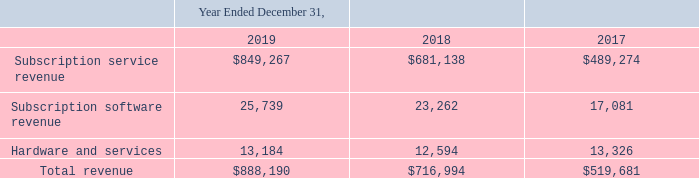Proofpoint, Inc. Notes to Consolidated Financial Statements (Continued) (dollars and share amounts in thousands, except per share amounts)
of the transaction price to each performance obligation based on a relative standalone selling price, or SSP, basis.
• Recognition of revenue when, or as, the Company satisfies a performance obligation - The Company recognizes revenue when control of the services or products are transferred to the customers, in an amount that reflects the consideration the Company expects to be entitled to in exchange for those services or products. The Company records its revenue net of any value added or sales tax.
The Company generates sales directly through its sales team and, to a growing extent, through its channel partners. Sales to channel partners are made at a discount and revenues are recorded at this discounted

The Company generates sales directly through its sales team and, to a growing extent, through its channel partners. Sales to channel partners are made at a discount and revenues are recorded at this discounted price once all revenue recognition criteria are met. Channel partners generally receive an order from an end-customer prior to placing an order with the Company, and these partners do not carry any inventory of the Company’s products or solutions. Payment from channel partners is not contingent on the partner’s success in sales to end-customers. In the event that the Company offers rebates, joint marketing funds, or other incentive programs to a partner, recorded revenues are reduced by these amounts accordingly.
Payment terms on invoiced amounts are typically 30 to 45 days.
Disaggregation of Revenue Disaggregation of Revenue
The Company derives its revenue primarily from: (1) subscription service revenue; (2) subscription software revenue, and (3) hardware and services, which include professional service and training revenue provided to customers related to their use of the platform.
The following table presents the Company’s revenue disaggregation:
Subscription service revenue
Subscription service revenue is derived from a subscription-based enterprise licensing model with contract terms typically ranging from one to three years, and consists of (1) subscription fees from the licensing of the Company’s security-as-a-service platform and it’s various components, (2) subscription fees for software with support and related future updates where the software updates are critical to the customers’ ability to derive benefit from the software due to the fast changing nature of the technology. These function together as one performance obligation, and (3) subscription fees for the right to access the Company’s customer support services for software with significant standalone functionality and support services for hardware. The hosted on-demand service arrangements do not provide customers with the right to take possession of the software supporting the hosted services. Support revenue is derived from ongoing security updates, upgrades, bug fixes, and maintenance. A time-elapsed method is used to measure progress because the Company transfers control evenly over the contractual period. Accordingly, the fixed consideration related to subscription service revenue is generally recognized on a straight-line basis over the contract term beginning on the date access is provided, as long as other revenue recognition criteria have been met. Most of the Company’s contracts are non-inate their contract for cause if the 

Subscription service revenue is derived from a subscription-based enterprise licensing model with contract terms typically ranging from one to three years, and consists of (1) subscription fees from the licensing of the Company’s security-as-a-service platform and it’s various components, (2) subscription fees for software with support and related future updates where the software updates are critical to the customers’ ability to derive benefit from the software due to the fast changing nature of the technology. These function together as one performance obligation, and (3) subscription fees for the right to access the Company’s customer support services for software with significant standalone functionality and support services for hardware. The hosted on-demand service arrangements do not provide customers with the right to take possession of the software supporting the hosted services. Support revenue is derived from ongoing security updates, upgrades, bug fixes, and maintenance. A time-elapsed method is used to measure progress because the Company transfers control evenly over the contractual period. Accordingly, the fixed consideration related to subscription service revenue is generally recognized on a straight-line basis over the contract term beginning on the date access is provided, as long as other revenue recognition criteria have been met. Most of the Company’s contracts are non-cancelable over the contract term. Customers typically have the right to terminate their contract for cause if the Company fails to perform in accordance with the contractual terms. Some of the Company’s customers have the option to purchase additional subscription services at a stated price. These options are evaluated on a case-by-case basis but generally do not provide a material right as they are priced at or above the Company’s SSP and, as such, would not result in a separate performance obligation.
When is revenue being recognised by the company? When control of the services or products are transferred to the customers, in an amount that reflects the consideration the company expects to be entitled to in exchange for those services or products. What method is used to measure the progression of how the company transfer its control? Time-elapsed method. What does support revenue consists of?  Ongoing security updates, upgrades, bug fixes, and maintenance. What percentage is the total revenue is from Hardware and services in year 2019?
Answer scale should be: percent. 13,184 / 888,190
Answer: 1.48. How many percent did the revenue increase from the year 2017 to 2018?
Answer scale should be: percent. (716,994 - 519,681) /519,681
Answer: 37.97. How much did Subscription service revenue increase from the year 2018 to 2019?
Answer scale should be: thousand. 849,267 - 681,138
Answer: 168129. 